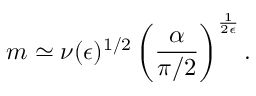Convert formula to latex. <formula><loc_0><loc_0><loc_500><loc_500>m \simeq \nu ( { \epsilon } ) ^ { 1 / 2 } \left ( \frac { \alpha } { \pi / 2 } \right ) ^ { \frac { 1 } { 2 \epsilon } } .</formula> 